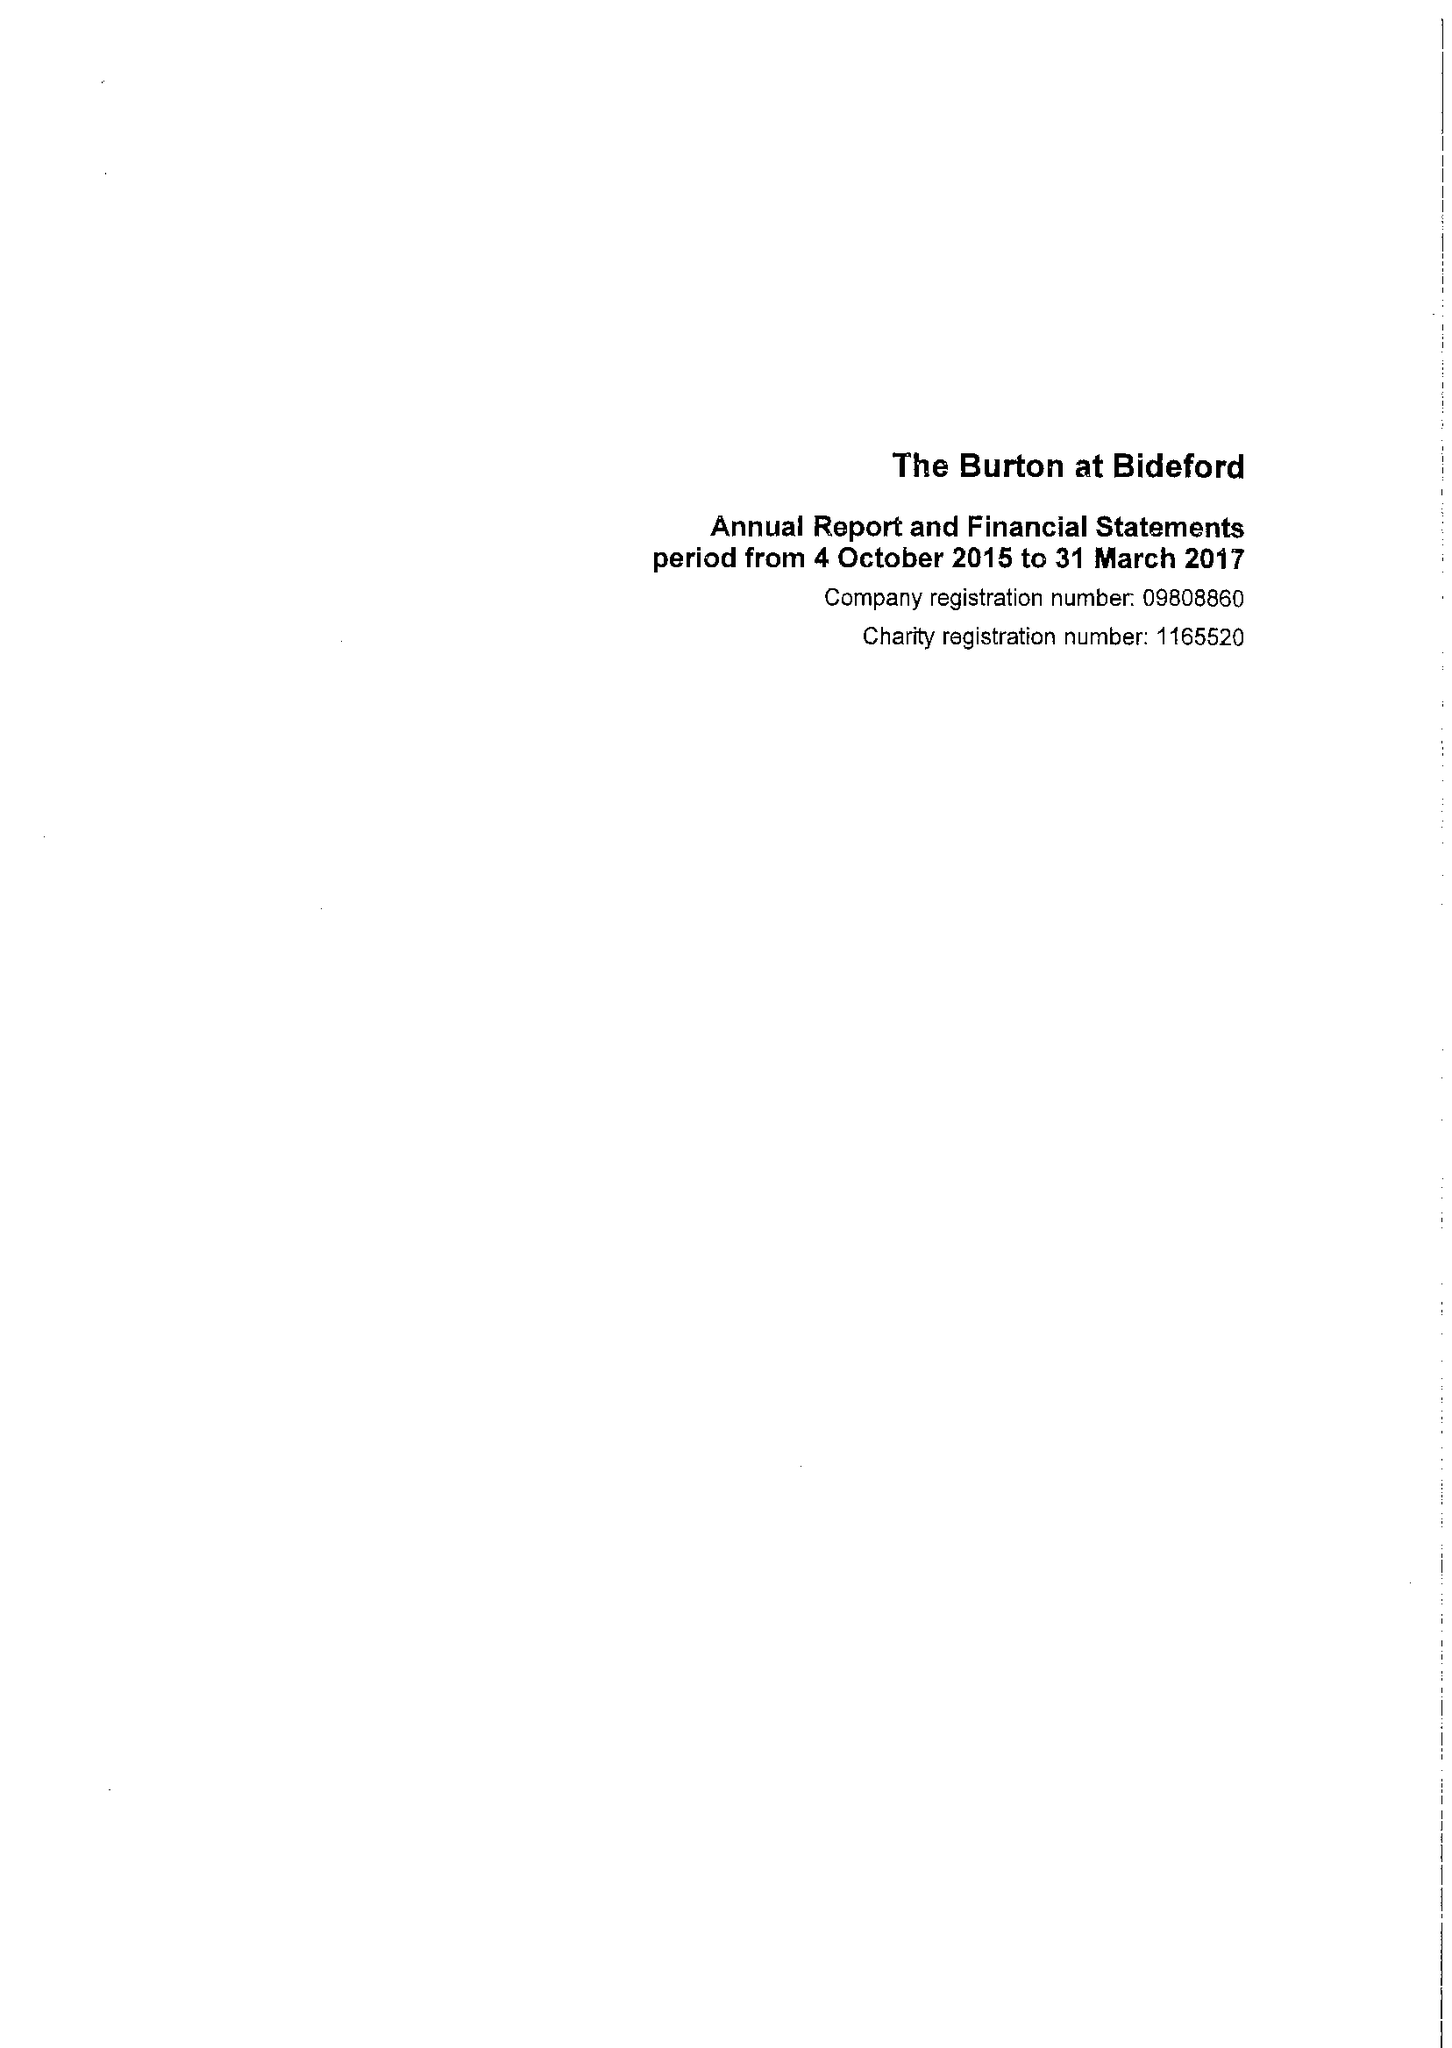What is the value for the report_date?
Answer the question using a single word or phrase. 2017-03-31 